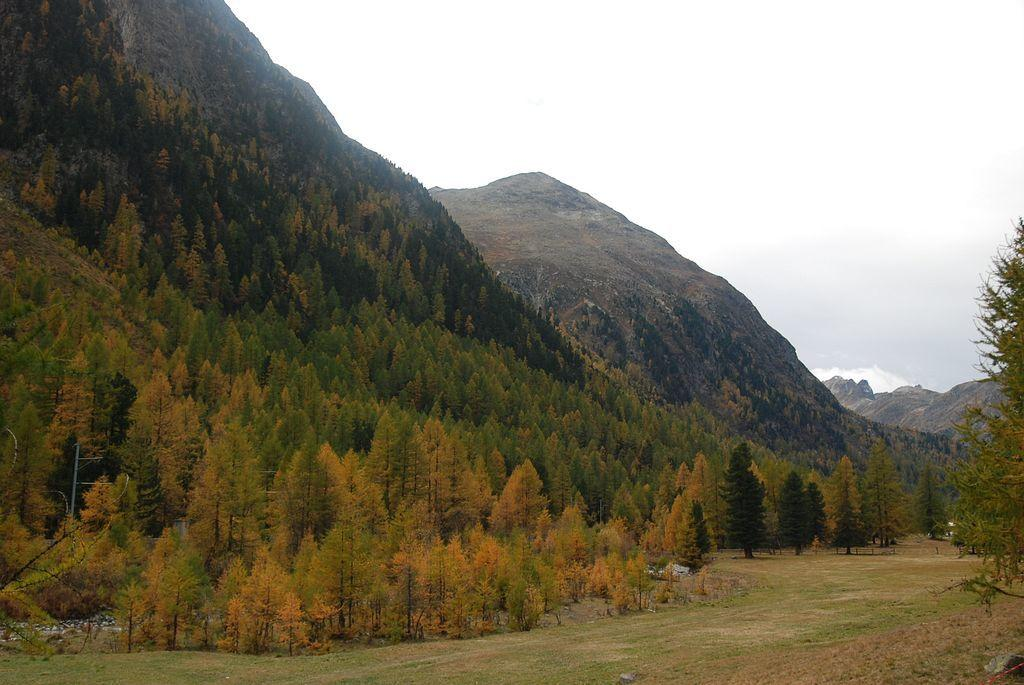What type of natural landscape is depicted in the image? The image features mountains, trees, and grass, which are all elements of a natural landscape. Can you describe the vegetation in the image? There are trees and grass visible in the image. What is visible in the sky in the image? The sky is visible in the image. Is there a rainstorm happening in the image? There is no indication of a rainstorm in the image; the sky appears to be clear. What type of meal is being prepared in the image? There is no meal preparation or any indication of food in the image. 